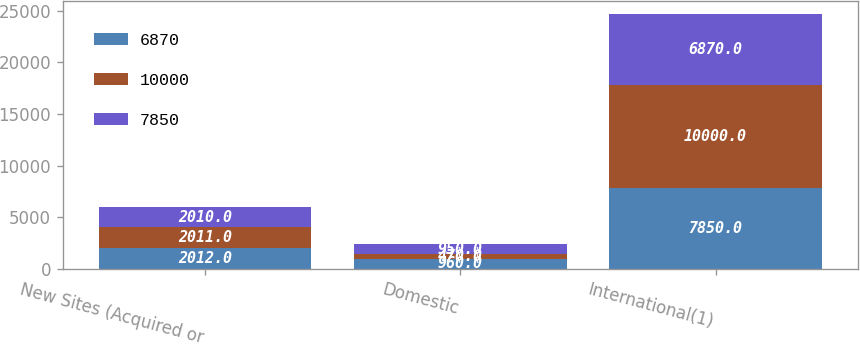Convert chart to OTSL. <chart><loc_0><loc_0><loc_500><loc_500><stacked_bar_chart><ecel><fcel>New Sites (Acquired or<fcel>Domestic<fcel>International(1)<nl><fcel>6870<fcel>2012<fcel>960<fcel>7850<nl><fcel>10000<fcel>2011<fcel>470<fcel>10000<nl><fcel>7850<fcel>2010<fcel>950<fcel>6870<nl></chart> 